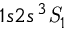<formula> <loc_0><loc_0><loc_500><loc_500>1 s 2 s ^ { 3 } { S } _ { 1 }</formula> 